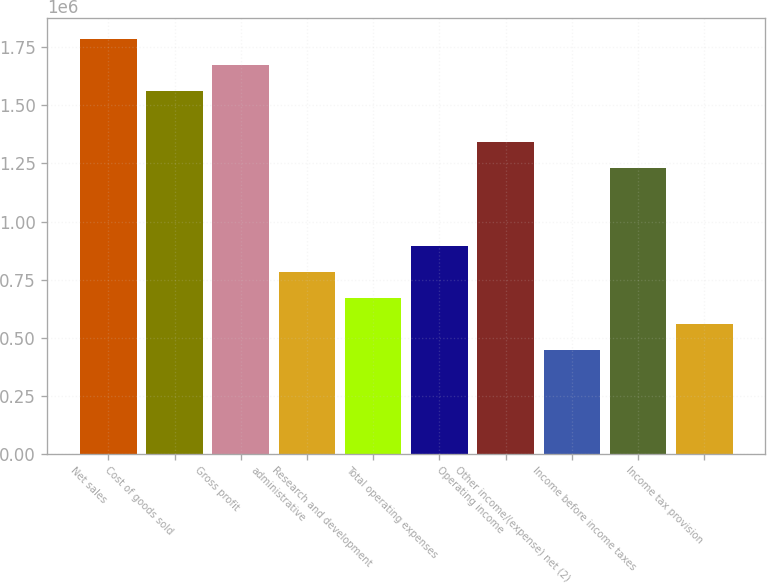Convert chart. <chart><loc_0><loc_0><loc_500><loc_500><bar_chart><fcel>Net sales<fcel>Cost of goods sold<fcel>Gross profit<fcel>administrative<fcel>Research and development<fcel>Total operating expenses<fcel>Operating income<fcel>Other income/(expense) net (2)<fcel>Income before income taxes<fcel>Income tax provision<nl><fcel>1.78783e+06<fcel>1.56435e+06<fcel>1.67609e+06<fcel>782174<fcel>670435<fcel>893913<fcel>1.34087e+06<fcel>446957<fcel>1.22913e+06<fcel>558696<nl></chart> 